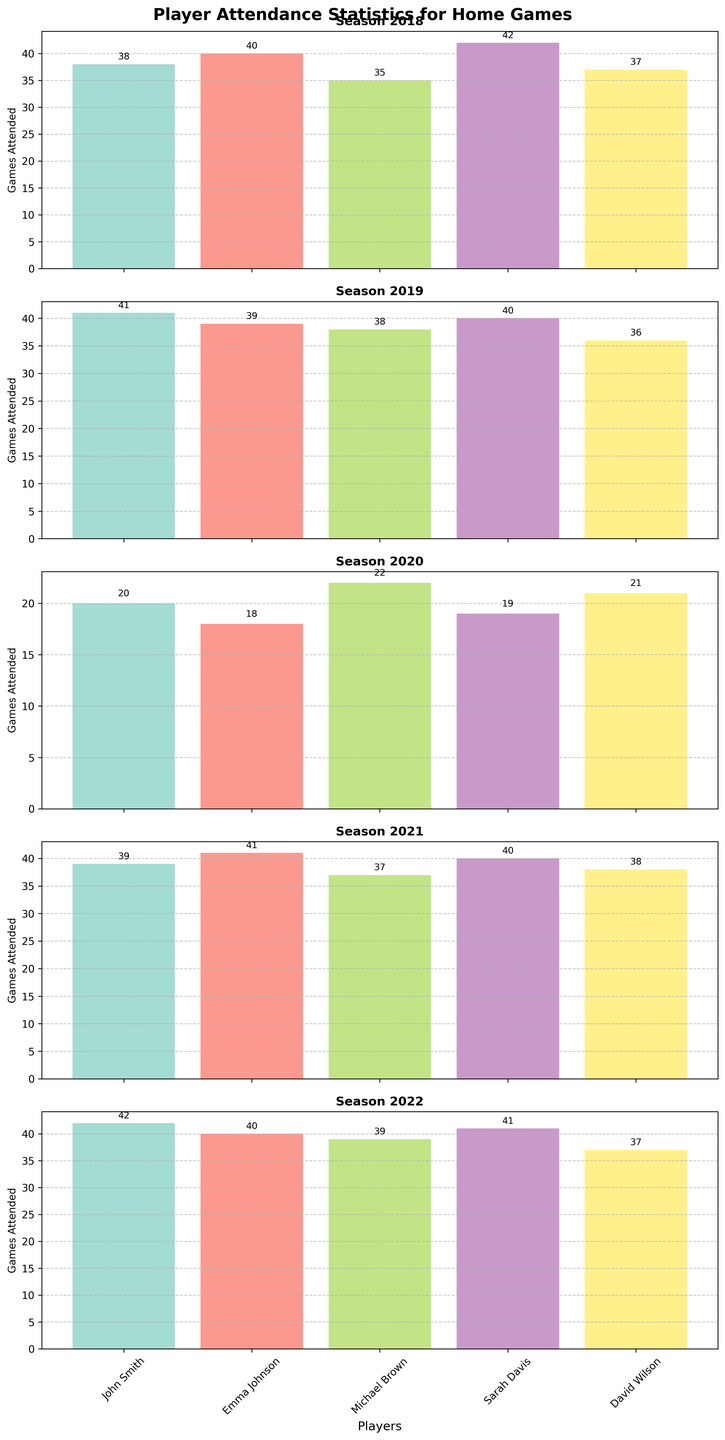Which player attended the most games in the 2020 season? In the subplot for the 2020 season, Sarah Davis attended 19 games which is visually the highest bar among all players for that season.
Answer: Sarah Davis Compare the attendance of John Smith in the 2021 and 2022 seasons. Which season had higher attendance? John Smith attended 39 games in the 2021 season and 42 games in the 2022 season. The bar for the 2022 season is higher.
Answer: 2022 Which player had the lowest attendance in the 2018 season? In the subplot for the 2018 season, Michael Brown attended 35 games which is the shortest bar among all players for that season.
Answer: Michael Brown Calculate the average number of games attended by Emma Johnson over the past 5 seasons. Emma Johnson's attendance over the 5 seasons is 40, 39, 18, 41, and 40. The sum of these values is 178, and there are 5 seasons, so the average is 178/5.
Answer: 35.6 Which season did Sarah Davis attend the most games? Examining all subplots, Sarah Davis attended 42 games in the 2018 season, which is the highest value across all seasons for her.
Answer: 2018 Did any player attend more than 40 games in any season besides John Smith and Sarah Davis? The subplots show that the only players with bars higher than 40 games are John Smith and Sarah Davis. No other player attended more than 40 games in any season.
Answer: No How did the 2020 season compare to other seasons for player attendance overall? The subplots show lower bar heights for all players in the 2020 season compared to the other seasons, indicating lower overall attendance.
Answer: Lower overall attendance What is the difference in the number of games attended by David Wilson between 2019 and 2021? David Wilson attended 36 games in 2019 and 38 games in 2021. The difference is 38 - 36.
Answer: 2 Which two players had the same number of games attended in any season, and in what season did it occur? In the subplot for the 2018 season, John Smith and David Wilson both attended 37 games as indicated by the bars of equal height.
Answer: John Smith and David Wilson, 2018 